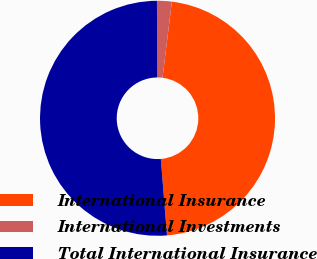Convert chart. <chart><loc_0><loc_0><loc_500><loc_500><pie_chart><fcel>International Insurance<fcel>International Investments<fcel>Total International Insurance<nl><fcel>46.77%<fcel>2.03%<fcel>51.21%<nl></chart> 